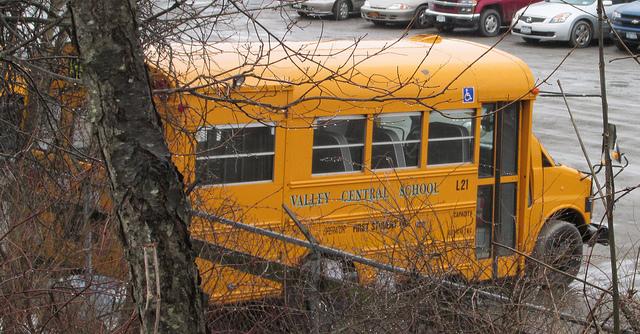How many windows are on the bus?
Keep it brief. 4. Is it raining?
Keep it brief. No. What is the school name printed on the bus?
Keep it brief. Valley central school. What is the word on the side of the bus?
Keep it brief. Valley central school. Is this bus new?
Concise answer only. Yes. Four windows on the bus?
Keep it brief. Yes. 